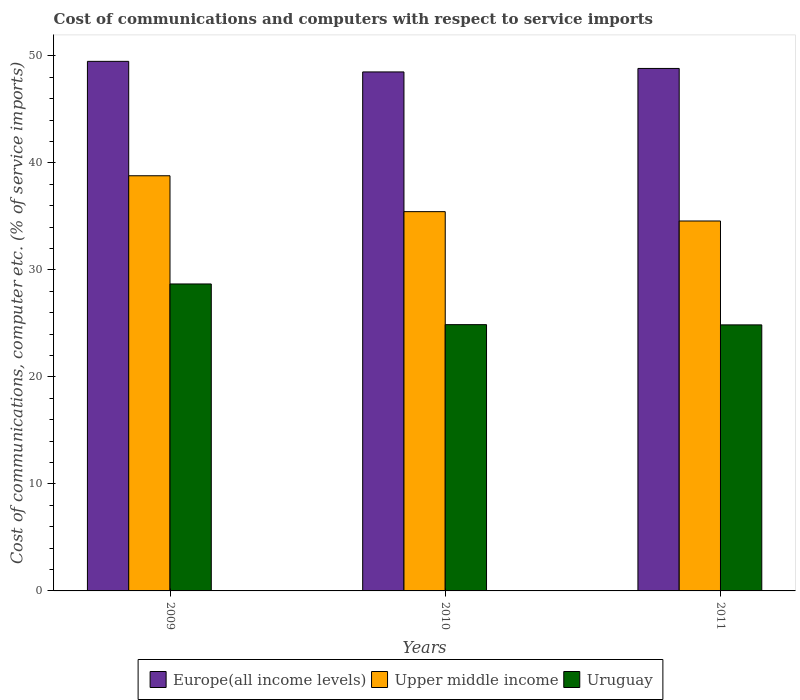How many different coloured bars are there?
Your answer should be compact. 3. How many groups of bars are there?
Your answer should be very brief. 3. Are the number of bars per tick equal to the number of legend labels?
Your answer should be very brief. Yes. Are the number of bars on each tick of the X-axis equal?
Give a very brief answer. Yes. What is the cost of communications and computers in Upper middle income in 2010?
Provide a succinct answer. 35.44. Across all years, what is the maximum cost of communications and computers in Upper middle income?
Your answer should be very brief. 38.79. Across all years, what is the minimum cost of communications and computers in Uruguay?
Your response must be concise. 24.86. In which year was the cost of communications and computers in Europe(all income levels) maximum?
Offer a terse response. 2009. In which year was the cost of communications and computers in Uruguay minimum?
Provide a succinct answer. 2011. What is the total cost of communications and computers in Europe(all income levels) in the graph?
Make the answer very short. 146.79. What is the difference between the cost of communications and computers in Upper middle income in 2010 and that in 2011?
Keep it short and to the point. 0.87. What is the difference between the cost of communications and computers in Upper middle income in 2010 and the cost of communications and computers in Uruguay in 2009?
Keep it short and to the point. 6.76. What is the average cost of communications and computers in Europe(all income levels) per year?
Your response must be concise. 48.93. In the year 2010, what is the difference between the cost of communications and computers in Upper middle income and cost of communications and computers in Uruguay?
Provide a succinct answer. 10.56. In how many years, is the cost of communications and computers in Europe(all income levels) greater than 28 %?
Keep it short and to the point. 3. What is the ratio of the cost of communications and computers in Europe(all income levels) in 2010 to that in 2011?
Your response must be concise. 0.99. What is the difference between the highest and the second highest cost of communications and computers in Upper middle income?
Your response must be concise. 3.35. What is the difference between the highest and the lowest cost of communications and computers in Upper middle income?
Your answer should be very brief. 4.23. Is the sum of the cost of communications and computers in Europe(all income levels) in 2009 and 2010 greater than the maximum cost of communications and computers in Uruguay across all years?
Your answer should be compact. Yes. What does the 3rd bar from the left in 2009 represents?
Give a very brief answer. Uruguay. What does the 1st bar from the right in 2011 represents?
Provide a succinct answer. Uruguay. How many bars are there?
Provide a succinct answer. 9. Are the values on the major ticks of Y-axis written in scientific E-notation?
Offer a very short reply. No. Does the graph contain any zero values?
Offer a very short reply. No. Where does the legend appear in the graph?
Provide a succinct answer. Bottom center. What is the title of the graph?
Your answer should be very brief. Cost of communications and computers with respect to service imports. Does "Germany" appear as one of the legend labels in the graph?
Offer a terse response. No. What is the label or title of the Y-axis?
Offer a very short reply. Cost of communications, computer etc. (% of service imports). What is the Cost of communications, computer etc. (% of service imports) in Europe(all income levels) in 2009?
Keep it short and to the point. 49.48. What is the Cost of communications, computer etc. (% of service imports) of Upper middle income in 2009?
Provide a succinct answer. 38.79. What is the Cost of communications, computer etc. (% of service imports) in Uruguay in 2009?
Provide a short and direct response. 28.68. What is the Cost of communications, computer etc. (% of service imports) in Europe(all income levels) in 2010?
Keep it short and to the point. 48.49. What is the Cost of communications, computer etc. (% of service imports) of Upper middle income in 2010?
Make the answer very short. 35.44. What is the Cost of communications, computer etc. (% of service imports) in Uruguay in 2010?
Your response must be concise. 24.88. What is the Cost of communications, computer etc. (% of service imports) of Europe(all income levels) in 2011?
Offer a terse response. 48.82. What is the Cost of communications, computer etc. (% of service imports) in Upper middle income in 2011?
Make the answer very short. 34.57. What is the Cost of communications, computer etc. (% of service imports) of Uruguay in 2011?
Offer a terse response. 24.86. Across all years, what is the maximum Cost of communications, computer etc. (% of service imports) in Europe(all income levels)?
Your answer should be very brief. 49.48. Across all years, what is the maximum Cost of communications, computer etc. (% of service imports) of Upper middle income?
Offer a very short reply. 38.79. Across all years, what is the maximum Cost of communications, computer etc. (% of service imports) in Uruguay?
Offer a terse response. 28.68. Across all years, what is the minimum Cost of communications, computer etc. (% of service imports) in Europe(all income levels)?
Ensure brevity in your answer.  48.49. Across all years, what is the minimum Cost of communications, computer etc. (% of service imports) of Upper middle income?
Keep it short and to the point. 34.57. Across all years, what is the minimum Cost of communications, computer etc. (% of service imports) of Uruguay?
Give a very brief answer. 24.86. What is the total Cost of communications, computer etc. (% of service imports) of Europe(all income levels) in the graph?
Ensure brevity in your answer.  146.79. What is the total Cost of communications, computer etc. (% of service imports) in Upper middle income in the graph?
Make the answer very short. 108.8. What is the total Cost of communications, computer etc. (% of service imports) of Uruguay in the graph?
Provide a short and direct response. 78.42. What is the difference between the Cost of communications, computer etc. (% of service imports) in Upper middle income in 2009 and that in 2010?
Make the answer very short. 3.35. What is the difference between the Cost of communications, computer etc. (% of service imports) of Uruguay in 2009 and that in 2010?
Offer a very short reply. 3.8. What is the difference between the Cost of communications, computer etc. (% of service imports) of Europe(all income levels) in 2009 and that in 2011?
Ensure brevity in your answer.  0.66. What is the difference between the Cost of communications, computer etc. (% of service imports) in Upper middle income in 2009 and that in 2011?
Give a very brief answer. 4.23. What is the difference between the Cost of communications, computer etc. (% of service imports) in Uruguay in 2009 and that in 2011?
Provide a succinct answer. 3.82. What is the difference between the Cost of communications, computer etc. (% of service imports) of Europe(all income levels) in 2010 and that in 2011?
Make the answer very short. -0.33. What is the difference between the Cost of communications, computer etc. (% of service imports) of Upper middle income in 2010 and that in 2011?
Offer a terse response. 0.87. What is the difference between the Cost of communications, computer etc. (% of service imports) in Uruguay in 2010 and that in 2011?
Provide a short and direct response. 0.02. What is the difference between the Cost of communications, computer etc. (% of service imports) of Europe(all income levels) in 2009 and the Cost of communications, computer etc. (% of service imports) of Upper middle income in 2010?
Provide a short and direct response. 14.04. What is the difference between the Cost of communications, computer etc. (% of service imports) in Europe(all income levels) in 2009 and the Cost of communications, computer etc. (% of service imports) in Uruguay in 2010?
Your answer should be compact. 24.6. What is the difference between the Cost of communications, computer etc. (% of service imports) of Upper middle income in 2009 and the Cost of communications, computer etc. (% of service imports) of Uruguay in 2010?
Provide a short and direct response. 13.91. What is the difference between the Cost of communications, computer etc. (% of service imports) of Europe(all income levels) in 2009 and the Cost of communications, computer etc. (% of service imports) of Upper middle income in 2011?
Your answer should be very brief. 14.92. What is the difference between the Cost of communications, computer etc. (% of service imports) of Europe(all income levels) in 2009 and the Cost of communications, computer etc. (% of service imports) of Uruguay in 2011?
Ensure brevity in your answer.  24.62. What is the difference between the Cost of communications, computer etc. (% of service imports) in Upper middle income in 2009 and the Cost of communications, computer etc. (% of service imports) in Uruguay in 2011?
Make the answer very short. 13.93. What is the difference between the Cost of communications, computer etc. (% of service imports) of Europe(all income levels) in 2010 and the Cost of communications, computer etc. (% of service imports) of Upper middle income in 2011?
Your answer should be compact. 13.93. What is the difference between the Cost of communications, computer etc. (% of service imports) of Europe(all income levels) in 2010 and the Cost of communications, computer etc. (% of service imports) of Uruguay in 2011?
Make the answer very short. 23.63. What is the difference between the Cost of communications, computer etc. (% of service imports) of Upper middle income in 2010 and the Cost of communications, computer etc. (% of service imports) of Uruguay in 2011?
Provide a short and direct response. 10.58. What is the average Cost of communications, computer etc. (% of service imports) of Europe(all income levels) per year?
Keep it short and to the point. 48.93. What is the average Cost of communications, computer etc. (% of service imports) of Upper middle income per year?
Provide a short and direct response. 36.27. What is the average Cost of communications, computer etc. (% of service imports) in Uruguay per year?
Keep it short and to the point. 26.14. In the year 2009, what is the difference between the Cost of communications, computer etc. (% of service imports) in Europe(all income levels) and Cost of communications, computer etc. (% of service imports) in Upper middle income?
Your answer should be very brief. 10.69. In the year 2009, what is the difference between the Cost of communications, computer etc. (% of service imports) of Europe(all income levels) and Cost of communications, computer etc. (% of service imports) of Uruguay?
Provide a succinct answer. 20.8. In the year 2009, what is the difference between the Cost of communications, computer etc. (% of service imports) of Upper middle income and Cost of communications, computer etc. (% of service imports) of Uruguay?
Keep it short and to the point. 10.11. In the year 2010, what is the difference between the Cost of communications, computer etc. (% of service imports) of Europe(all income levels) and Cost of communications, computer etc. (% of service imports) of Upper middle income?
Provide a succinct answer. 13.05. In the year 2010, what is the difference between the Cost of communications, computer etc. (% of service imports) of Europe(all income levels) and Cost of communications, computer etc. (% of service imports) of Uruguay?
Keep it short and to the point. 23.61. In the year 2010, what is the difference between the Cost of communications, computer etc. (% of service imports) in Upper middle income and Cost of communications, computer etc. (% of service imports) in Uruguay?
Offer a terse response. 10.56. In the year 2011, what is the difference between the Cost of communications, computer etc. (% of service imports) in Europe(all income levels) and Cost of communications, computer etc. (% of service imports) in Upper middle income?
Offer a terse response. 14.25. In the year 2011, what is the difference between the Cost of communications, computer etc. (% of service imports) in Europe(all income levels) and Cost of communications, computer etc. (% of service imports) in Uruguay?
Your answer should be compact. 23.96. In the year 2011, what is the difference between the Cost of communications, computer etc. (% of service imports) in Upper middle income and Cost of communications, computer etc. (% of service imports) in Uruguay?
Offer a terse response. 9.71. What is the ratio of the Cost of communications, computer etc. (% of service imports) in Europe(all income levels) in 2009 to that in 2010?
Provide a succinct answer. 1.02. What is the ratio of the Cost of communications, computer etc. (% of service imports) of Upper middle income in 2009 to that in 2010?
Ensure brevity in your answer.  1.09. What is the ratio of the Cost of communications, computer etc. (% of service imports) in Uruguay in 2009 to that in 2010?
Ensure brevity in your answer.  1.15. What is the ratio of the Cost of communications, computer etc. (% of service imports) in Europe(all income levels) in 2009 to that in 2011?
Your answer should be compact. 1.01. What is the ratio of the Cost of communications, computer etc. (% of service imports) of Upper middle income in 2009 to that in 2011?
Offer a very short reply. 1.12. What is the ratio of the Cost of communications, computer etc. (% of service imports) in Uruguay in 2009 to that in 2011?
Provide a succinct answer. 1.15. What is the ratio of the Cost of communications, computer etc. (% of service imports) of Europe(all income levels) in 2010 to that in 2011?
Give a very brief answer. 0.99. What is the ratio of the Cost of communications, computer etc. (% of service imports) in Upper middle income in 2010 to that in 2011?
Offer a very short reply. 1.03. What is the ratio of the Cost of communications, computer etc. (% of service imports) in Uruguay in 2010 to that in 2011?
Offer a very short reply. 1. What is the difference between the highest and the second highest Cost of communications, computer etc. (% of service imports) in Europe(all income levels)?
Give a very brief answer. 0.66. What is the difference between the highest and the second highest Cost of communications, computer etc. (% of service imports) of Upper middle income?
Offer a terse response. 3.35. What is the difference between the highest and the second highest Cost of communications, computer etc. (% of service imports) of Uruguay?
Keep it short and to the point. 3.8. What is the difference between the highest and the lowest Cost of communications, computer etc. (% of service imports) in Upper middle income?
Offer a very short reply. 4.23. What is the difference between the highest and the lowest Cost of communications, computer etc. (% of service imports) in Uruguay?
Ensure brevity in your answer.  3.82. 